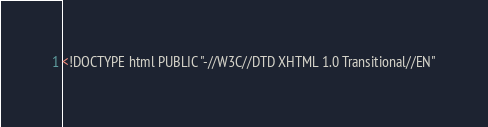Convert code to text. <code><loc_0><loc_0><loc_500><loc_500><_HTML_><!DOCTYPE html PUBLIC "-//W3C//DTD XHTML 1.0 Transitional//EN"</code> 